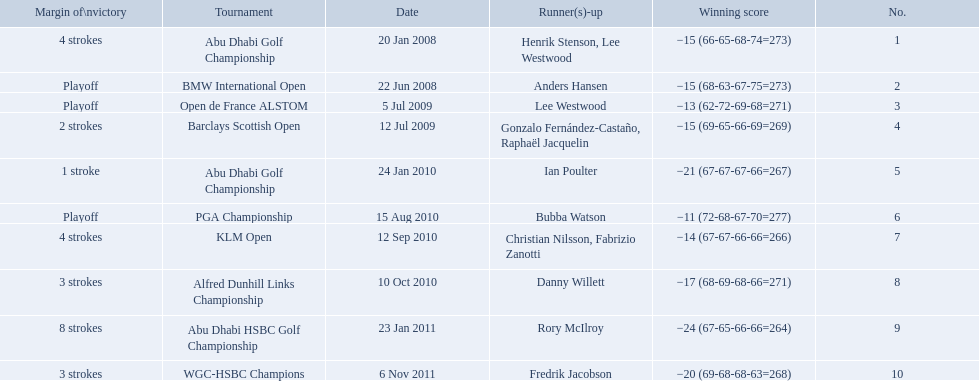What were all the different tournaments played by martin kaymer Abu Dhabi Golf Championship, BMW International Open, Open de France ALSTOM, Barclays Scottish Open, Abu Dhabi Golf Championship, PGA Championship, KLM Open, Alfred Dunhill Links Championship, Abu Dhabi HSBC Golf Championship, WGC-HSBC Champions. Who was the runner-up for the pga championship? Bubba Watson. Which tournaments did martin kaymer participate in? Abu Dhabi Golf Championship, BMW International Open, Open de France ALSTOM, Barclays Scottish Open, Abu Dhabi Golf Championship, PGA Championship, KLM Open, Alfred Dunhill Links Championship, Abu Dhabi HSBC Golf Championship, WGC-HSBC Champions. How many of these tournaments were won through a playoff? BMW International Open, Open de France ALSTOM, PGA Championship. Which of those tournaments took place in 2010? PGA Championship. Who had to top score next to martin kaymer for that tournament? Bubba Watson. 